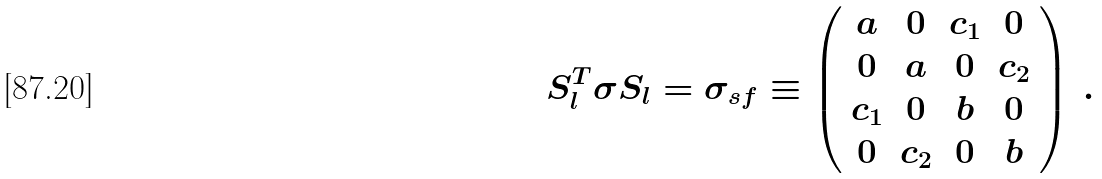Convert formula to latex. <formula><loc_0><loc_0><loc_500><loc_500>S _ { l } ^ { T } \sigma S _ { l } = \sigma _ { s f } \equiv \left ( \begin{array} { c c c c } a & 0 & c _ { 1 } & 0 \\ 0 & a & 0 & c _ { 2 } \\ c _ { 1 } & 0 & b & 0 \\ 0 & c _ { 2 } & 0 & b \end{array} \right ) \, .</formula> 